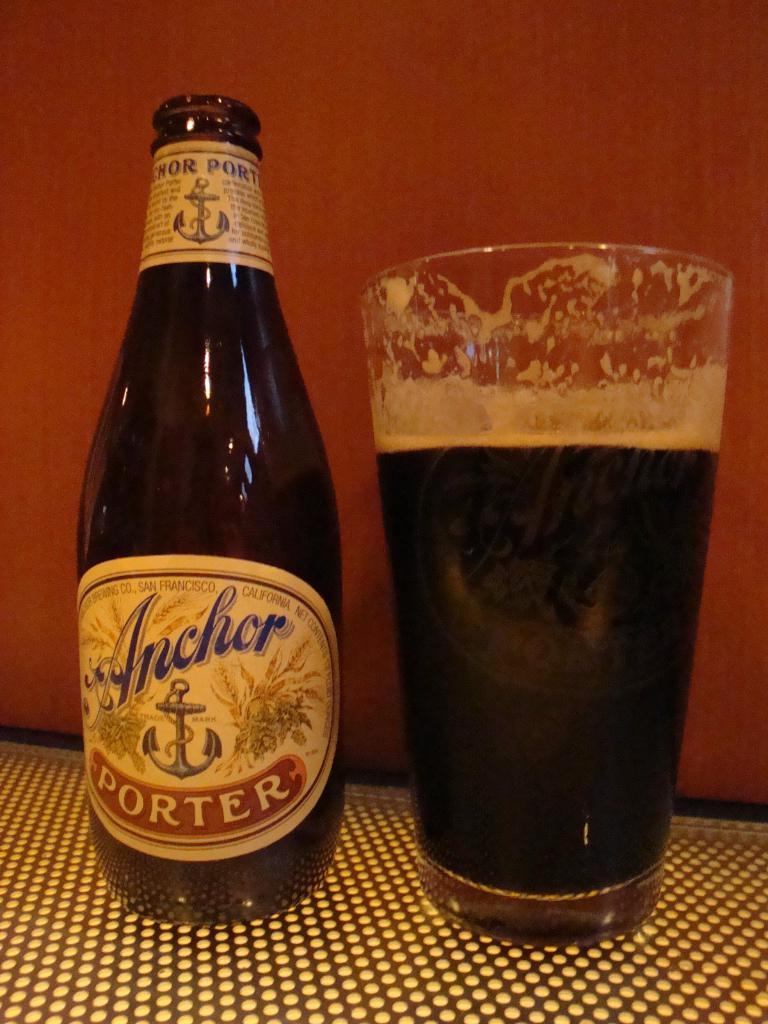What ship part is this beer named after?
Keep it short and to the point. Anchor. Is this beer made in san francisco?
Provide a short and direct response. Yes. 